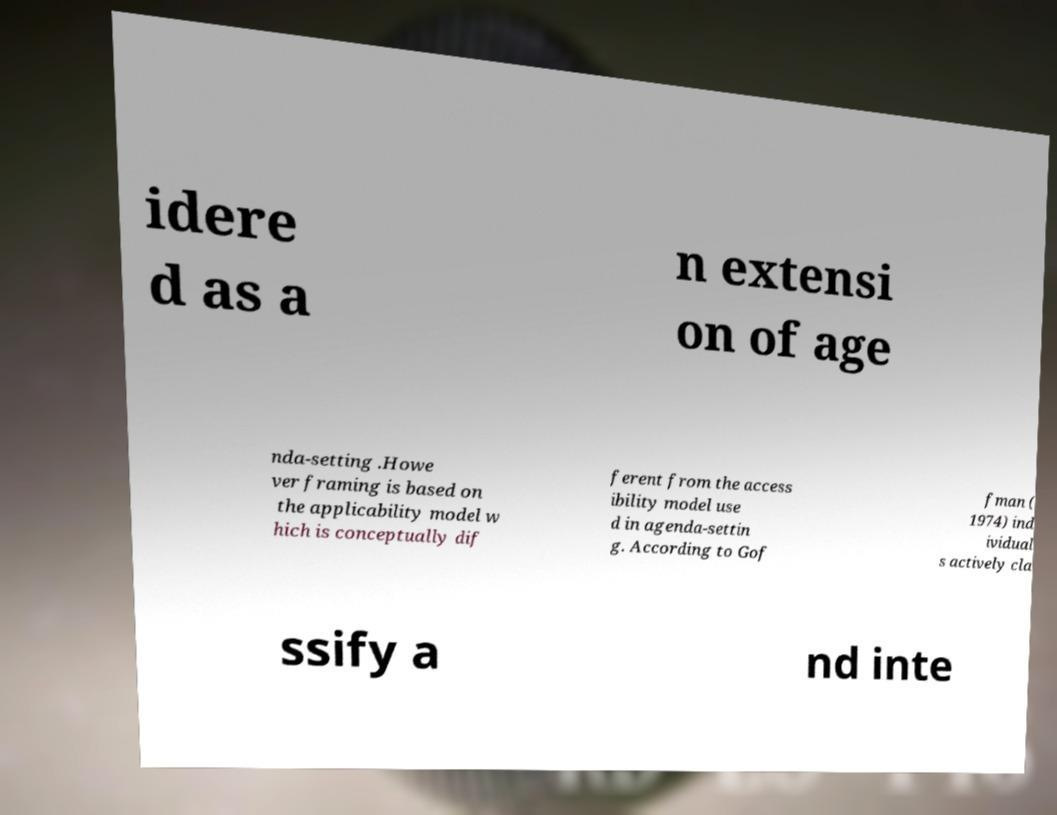I need the written content from this picture converted into text. Can you do that? idere d as a n extensi on of age nda-setting .Howe ver framing is based on the applicability model w hich is conceptually dif ferent from the access ibility model use d in agenda-settin g. According to Gof fman ( 1974) ind ividual s actively cla ssify a nd inte 